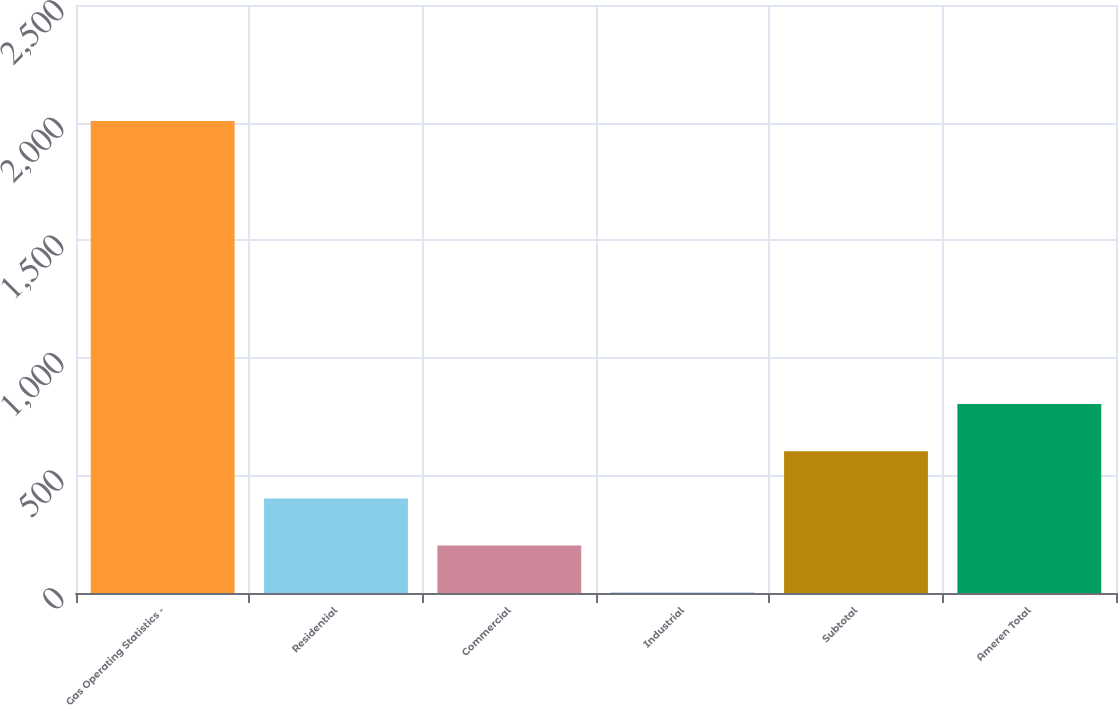Convert chart. <chart><loc_0><loc_0><loc_500><loc_500><bar_chart><fcel>Gas Operating Statistics -<fcel>Residential<fcel>Commercial<fcel>Industrial<fcel>Subtotal<fcel>Ameren Total<nl><fcel>2007<fcel>402.2<fcel>201.6<fcel>1<fcel>602.8<fcel>803.4<nl></chart> 